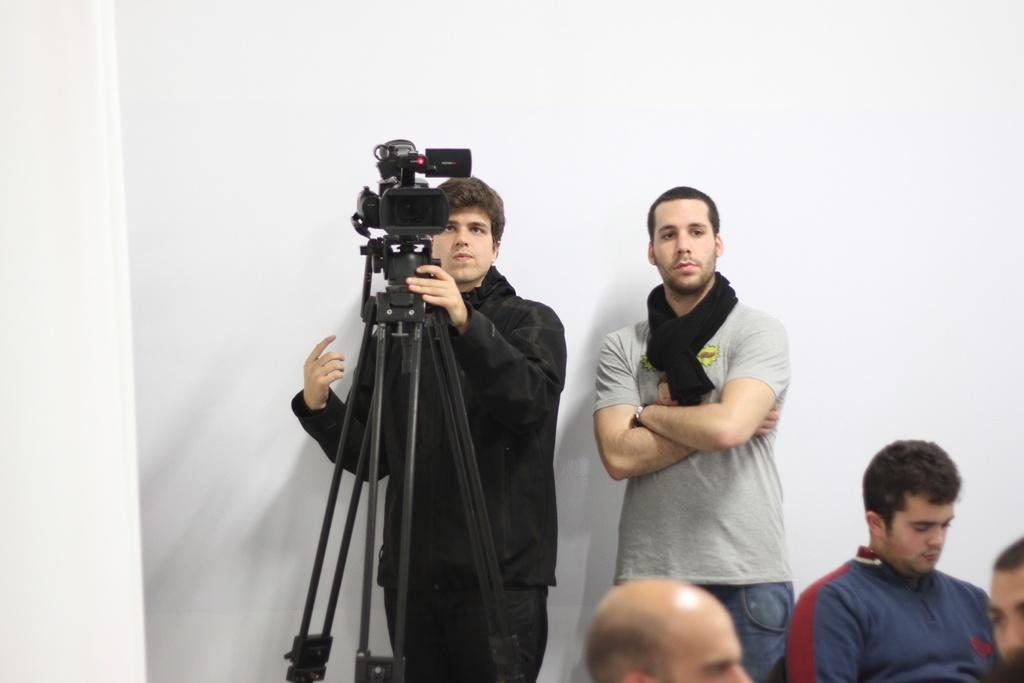How many people are in the image? There are people in the image, but the exact number is not specified. What is one person doing in the image? One person is holding a camera in the image. How is the camera positioned in the image? The camera is on a stand in the image. What is the color of the background in the image? The background of the image is white. What type of pie is being served to the person holding the toothbrush in the image? There is no pie or toothbrush present in the image. 